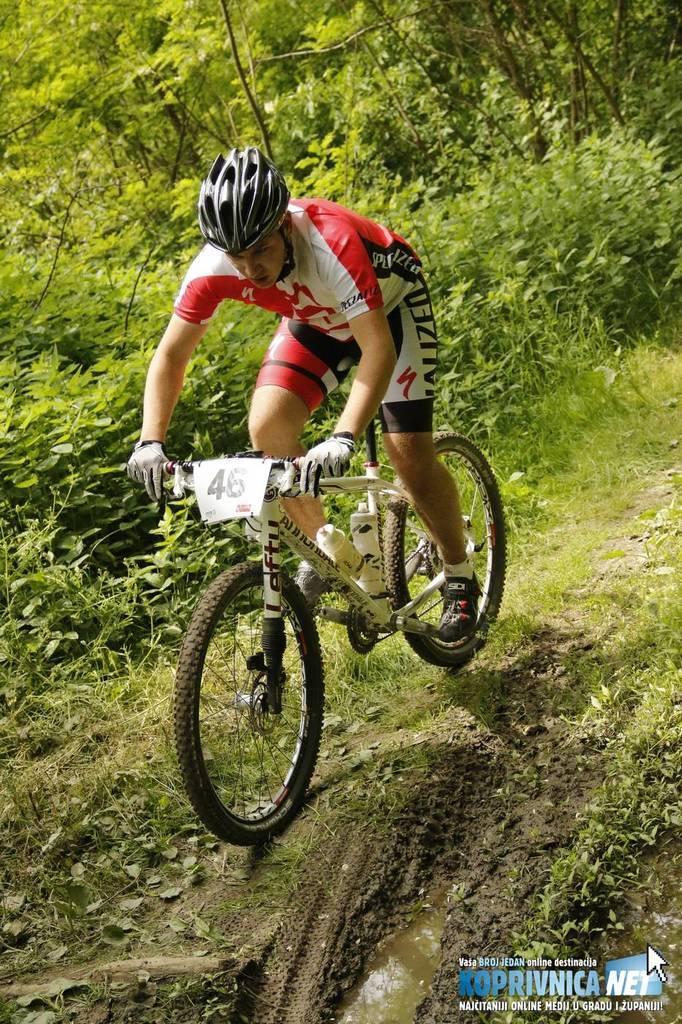Could you give a brief overview of what you see in this image? In this image, a person is riding a bicycle on the grass. In the background, trees are visible and a grass are visible. In the right bottom, a text is there. This image is taken during day time on the mountain. 